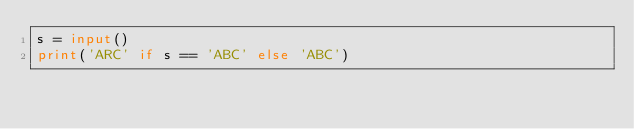Convert code to text. <code><loc_0><loc_0><loc_500><loc_500><_Python_>s = input()
print('ARC' if s == 'ABC' else 'ABC')
</code> 